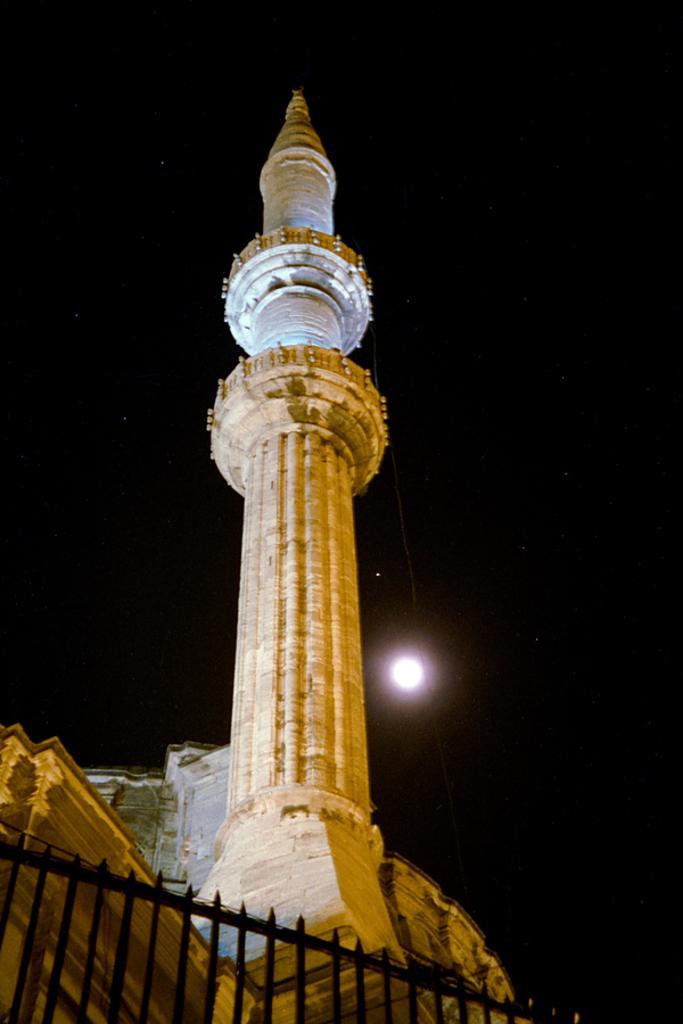Could you give a brief overview of what you see in this image? In the image we can see a tower, fence, dark sky and the moon. 